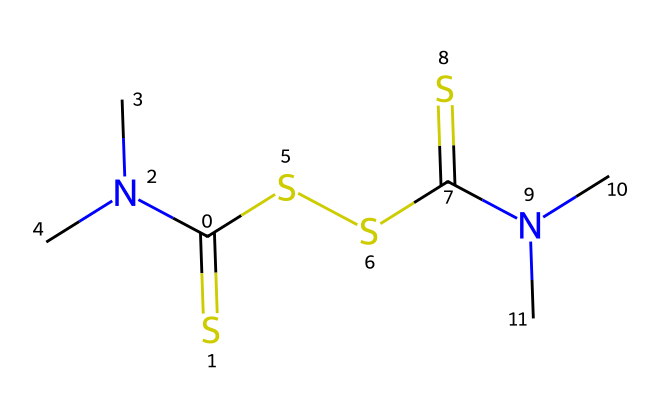What is the common name of this compound? The SMILES representation corresponds to thiram, which is recognized as a dithiocarbamate fungicide used in agriculture.
Answer: thiram How many carbon atoms are in the structure? By examining the SMILES, we can identify 6 carbon atoms (C) represented in various parts of the structure.
Answer: 6 What type of functional groups are present in this chemical? This compound contains thiol groups (due to the presence of sulfur) and amine groups (due to the nitrogen), which are characteristic of dithiocarbamates.
Answer: thiol and amine How many nitrogen atoms are present in this molecule? The SMILES indicates 2 nitrogen atoms (N) that are attached to carbon atoms, which confirms the presence of amine functional groups.
Answer: 2 Does thiram consist of more sulfur or nitrogen atoms? Counting the atoms in the structure, there are 4 sulfur atoms and 2 nitrogen atoms, indicating that sulfur is more prevalent in this molecule.
Answer: sulfur Which type of pesticide does this chemical belong to? Thiram is classified as a fungicide, specifically used to control fungal diseases in crops, making it an agricultural pesticide.
Answer: fungicide 